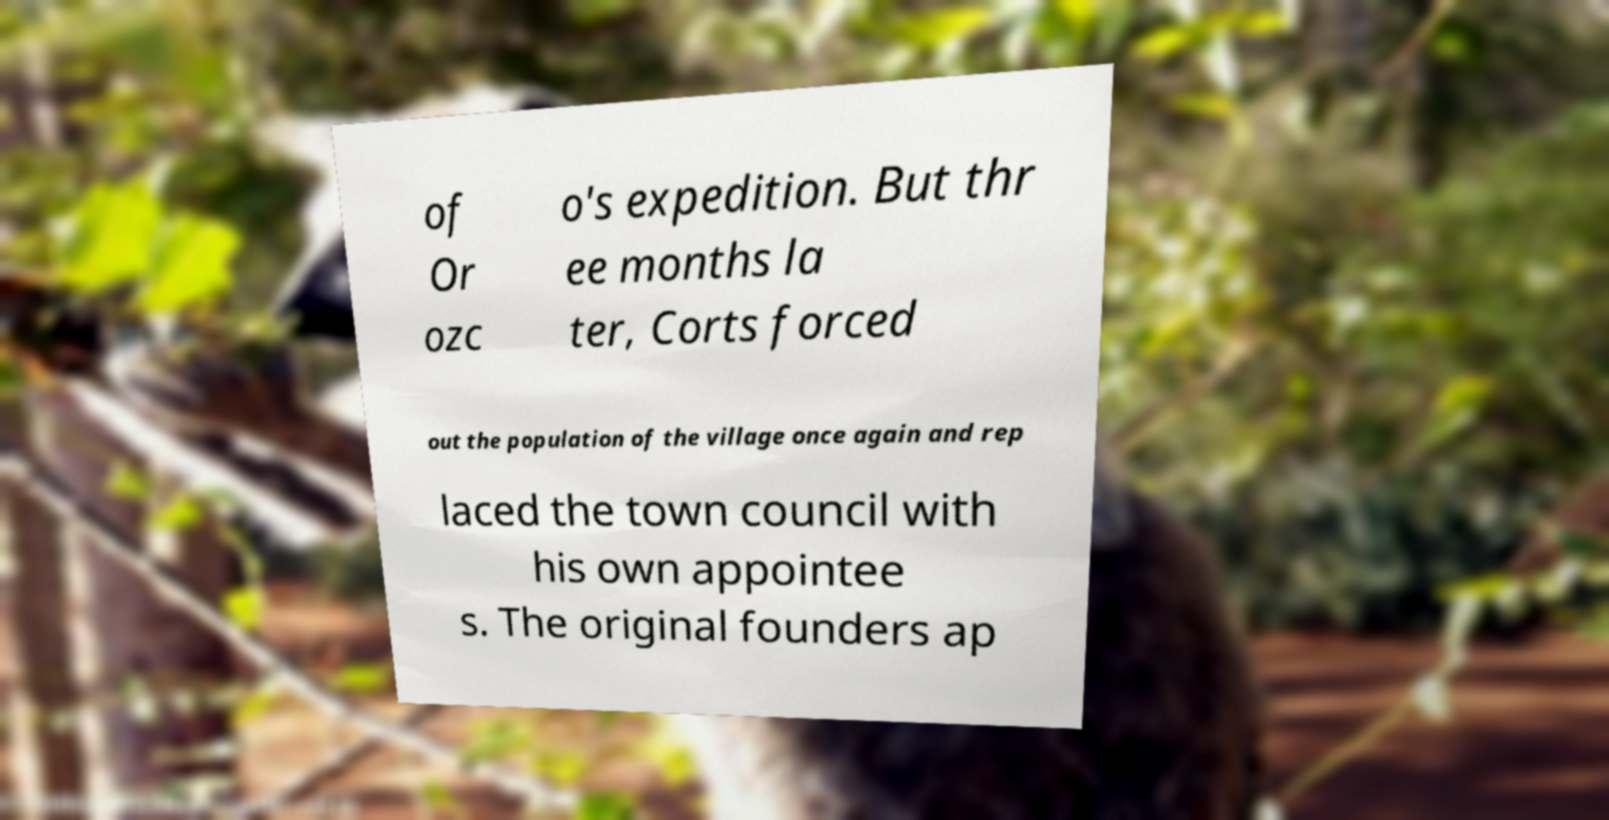Could you assist in decoding the text presented in this image and type it out clearly? of Or ozc o's expedition. But thr ee months la ter, Corts forced out the population of the village once again and rep laced the town council with his own appointee s. The original founders ap 